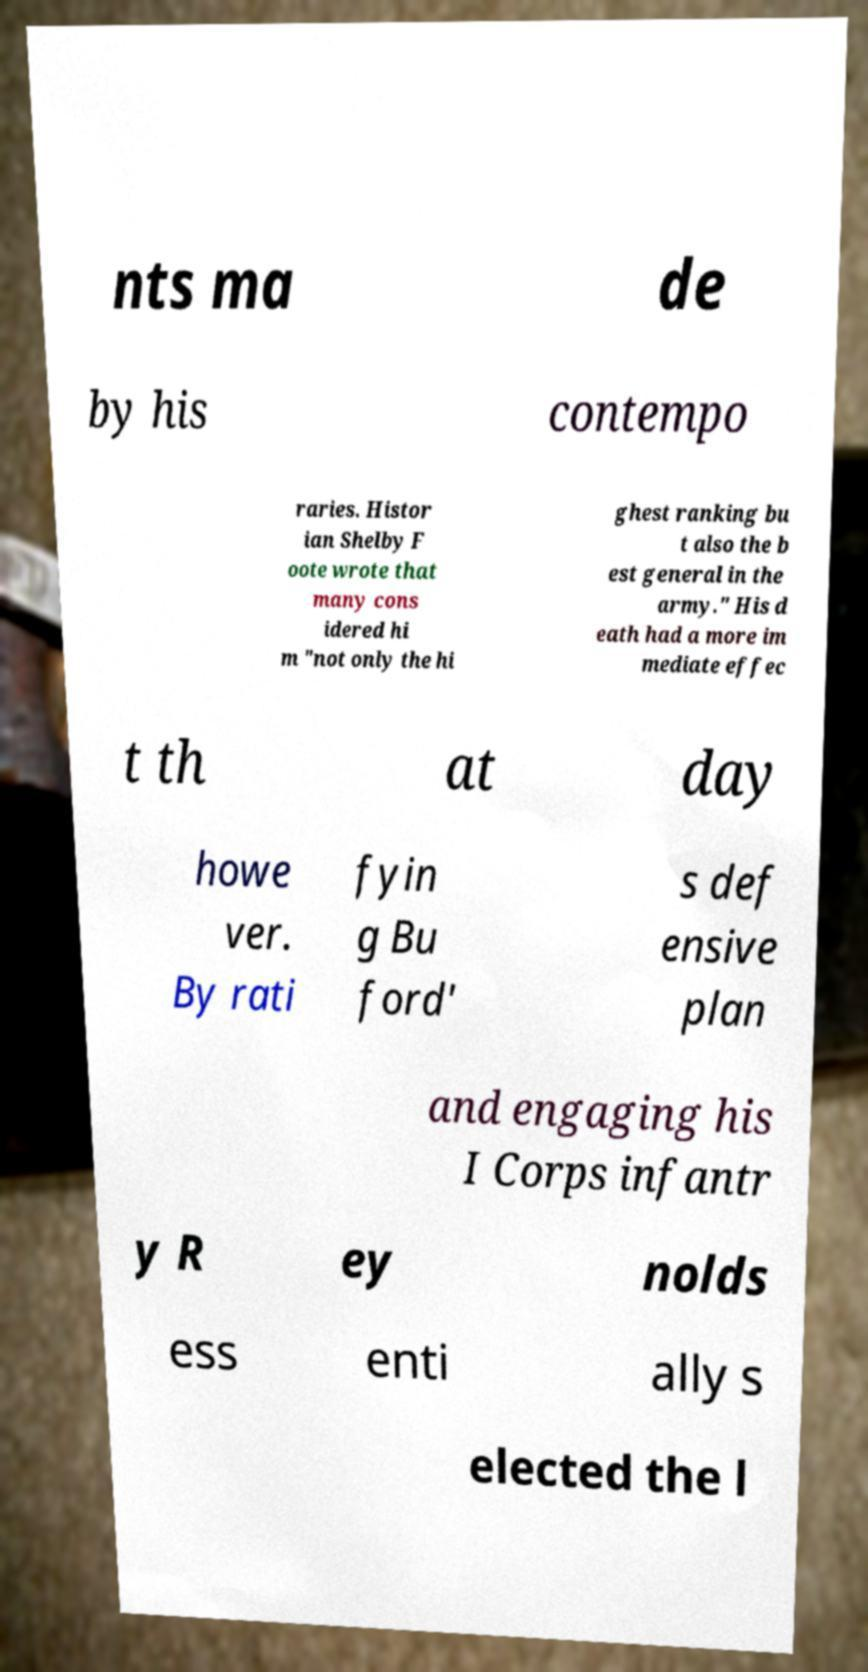Could you extract and type out the text from this image? nts ma de by his contempo raries. Histor ian Shelby F oote wrote that many cons idered hi m "not only the hi ghest ranking bu t also the b est general in the army." His d eath had a more im mediate effec t th at day howe ver. By rati fyin g Bu ford' s def ensive plan and engaging his I Corps infantr y R ey nolds ess enti ally s elected the l 